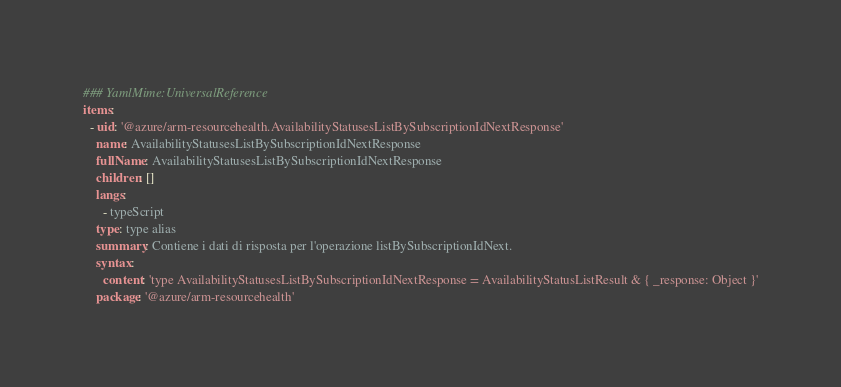Convert code to text. <code><loc_0><loc_0><loc_500><loc_500><_YAML_>### YamlMime:UniversalReference
items:
  - uid: '@azure/arm-resourcehealth.AvailabilityStatusesListBySubscriptionIdNextResponse'
    name: AvailabilityStatusesListBySubscriptionIdNextResponse
    fullName: AvailabilityStatusesListBySubscriptionIdNextResponse
    children: []
    langs:
      - typeScript
    type: type alias
    summary: Contiene i dati di risposta per l'operazione listBySubscriptionIdNext.
    syntax:
      content: 'type AvailabilityStatusesListBySubscriptionIdNextResponse = AvailabilityStatusListResult & { _response: Object }'
    package: '@azure/arm-resourcehealth'</code> 